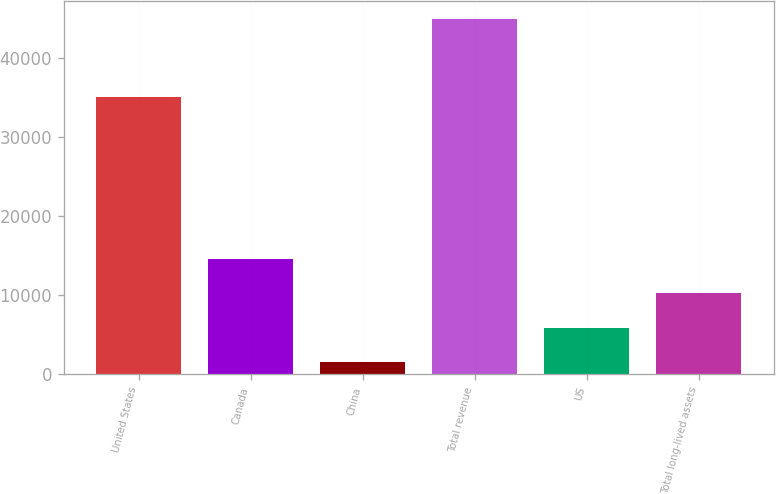Convert chart. <chart><loc_0><loc_0><loc_500><loc_500><bar_chart><fcel>United States<fcel>Canada<fcel>China<fcel>Total revenue<fcel>US<fcel>Total long-lived assets<nl><fcel>35070<fcel>14595.1<fcel>1558<fcel>45015<fcel>5903.7<fcel>10249.4<nl></chart> 